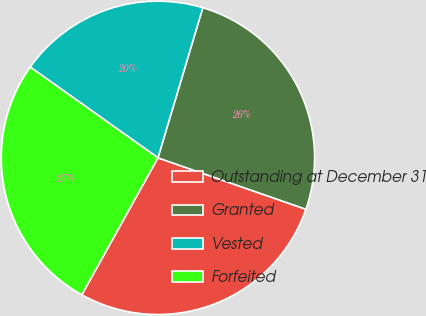Convert chart. <chart><loc_0><loc_0><loc_500><loc_500><pie_chart><fcel>Outstanding at December 31<fcel>Granted<fcel>Vested<fcel>Forfeited<nl><fcel>27.75%<fcel>25.7%<fcel>19.79%<fcel>26.76%<nl></chart> 